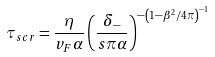Convert formula to latex. <formula><loc_0><loc_0><loc_500><loc_500>\tau _ { s c r } = \frac { \eta } { v _ { F } \alpha } \left ( \frac { \delta _ { - } } { s \pi \alpha } \right ) ^ { - \left ( 1 - \beta ^ { 2 } / 4 \pi \right ) ^ { - 1 } }</formula> 